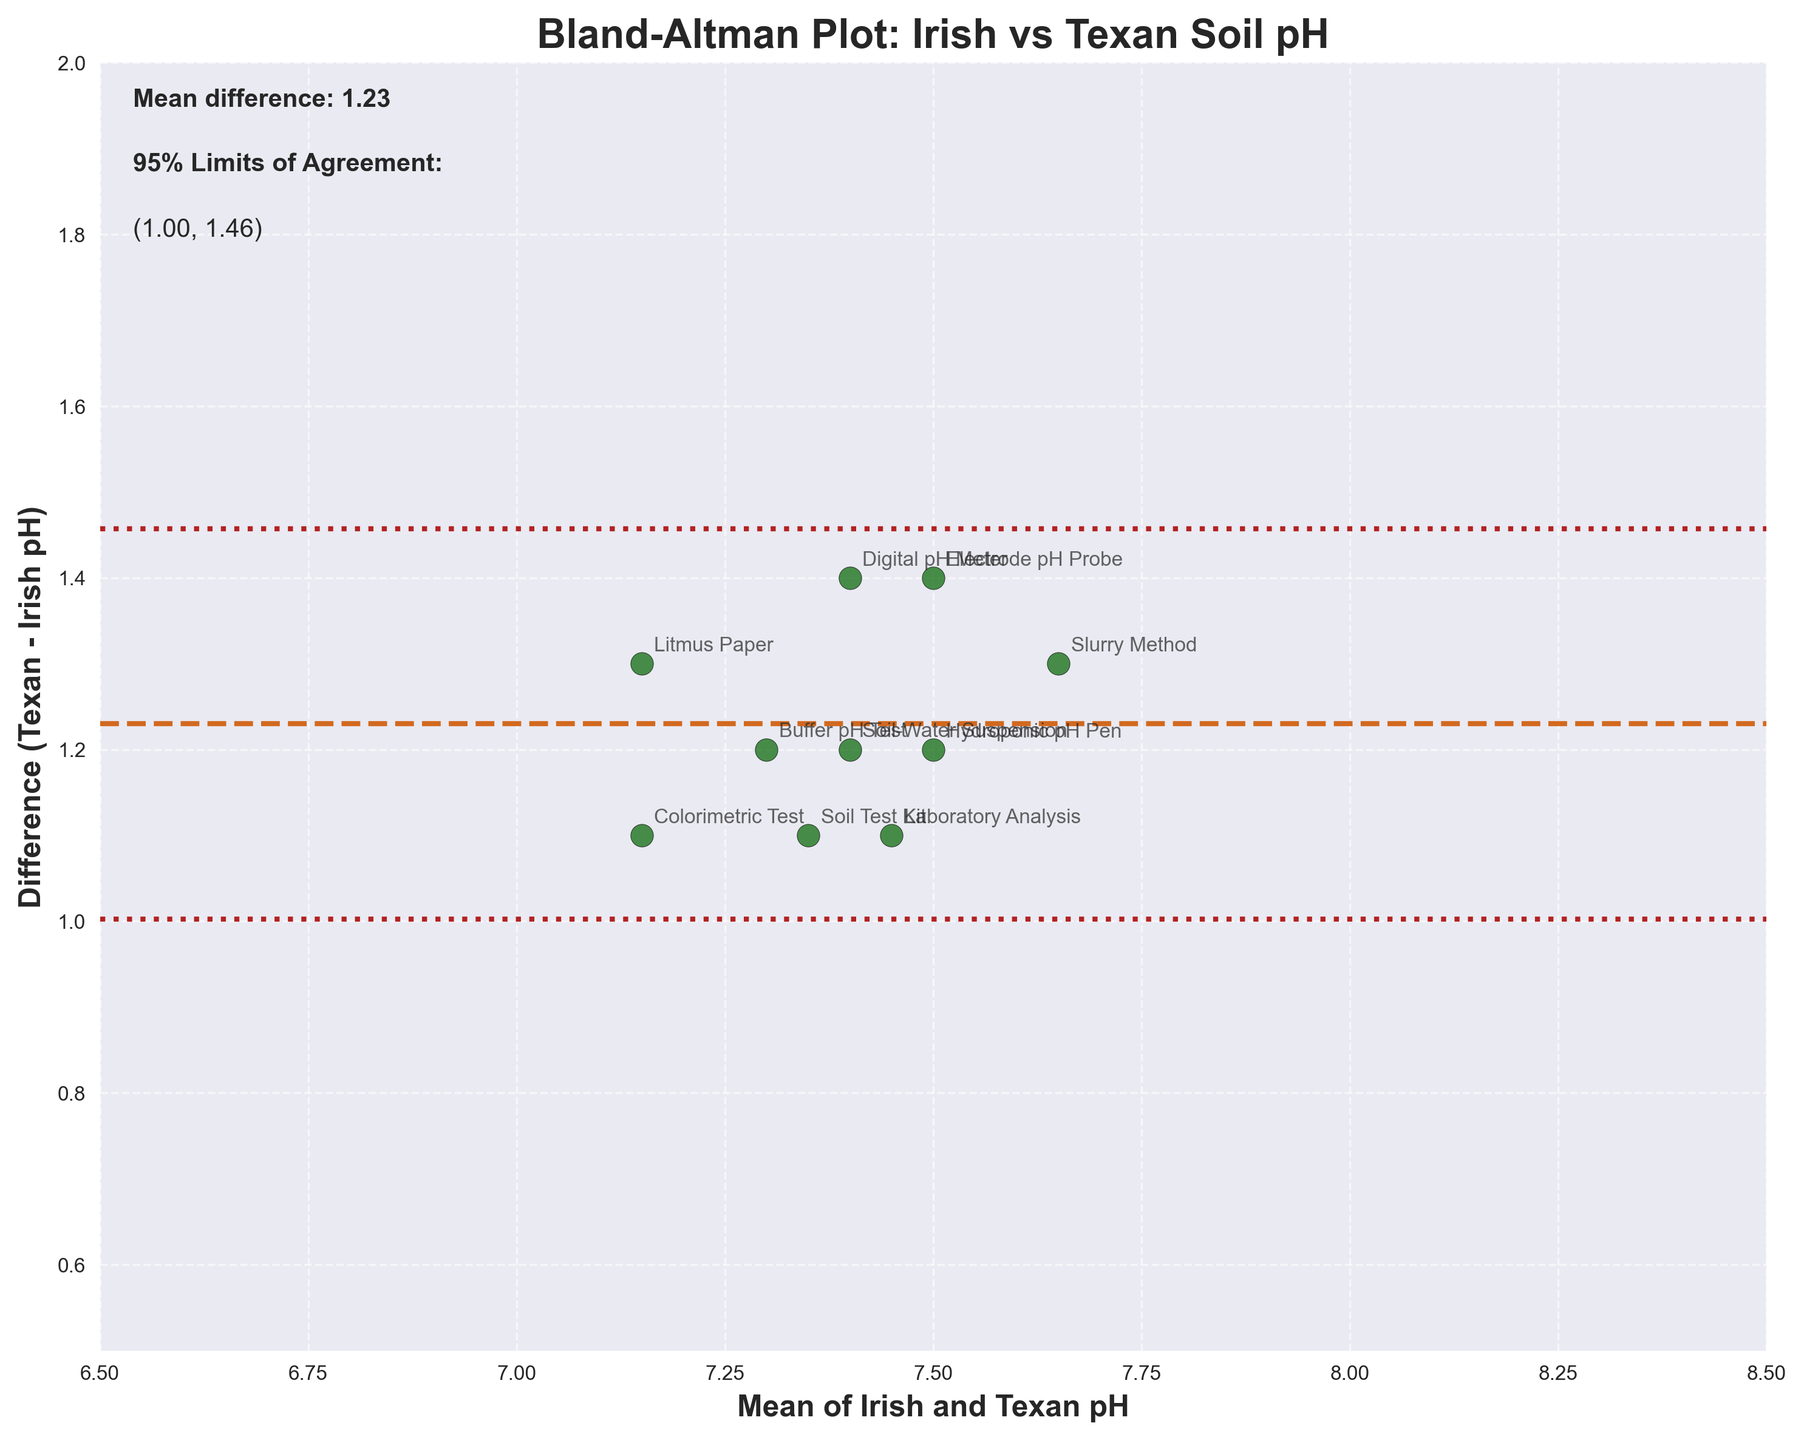How many data points are shown in the figure? The figure shows a scatter plot with labeled data points, each corresponding to a different testing method. By counting the labels, we can determine the number of data points.
Answer: 10 What is the title of the figure? The title is written at the top of the figure in bold font.
Answer: Bland-Altman Plot: Irish vs Texan Soil pH What is the mean difference between the Texan and Irish pH measurements? The mean difference is indicated by a horizontal dashed line labeled with "Mean difference" and its value.
Answer: 1.29 What are the 95% limits of agreement for the pH differences? The 95% limits of agreement are shown as dotted lines above and below the mean difference line. Their values are also given as text on the plot.
Answer: (1.02, 1.56) Which testing method has the highest positive difference between Texan and Irish pH measurements? By looking at the scatter plot, find the point with the highest vertical position (largest difference) and identify the label.
Answer: Slurry Method What is the average pH measurement of Texan gardens using the Laboratory Analysis method? For the Laboratory Analysis method, find the data point on the scatter plot, and note the Texan pH measurement annotated beside it.
Answer: 8.0 What testing method shows a mean pH of 7.05? Check each data point's mean pH value (x-axis) and find the one closest to 7.05. Identify the corresponding testing method label.
Answer: Electrode pH Probe Are there any testing methods where the Texan pH measurement is lower than 7.8? By examining each point's vertical position on the y-axis and comparing the Texan pH values, determine if any point indicates a Texan pH measurement lower than 7.8.
Answer: No How does the difference between Texan and Irish pH measurements vary across different pH levels? Observe the overall trend in the scatter plot to determine if differences increase or decrease with the mean pH levels on the x-axis.
Answer: Differences generally increase Is the pH of the Irish gardens more acidic or basic compared to the Texan gardens? Compare the general range of pH values for Irish and Texan gardens by examining the data points’ vertical positions. Note that a higher pH indicates a more basic condition.
Answer: More acidic 